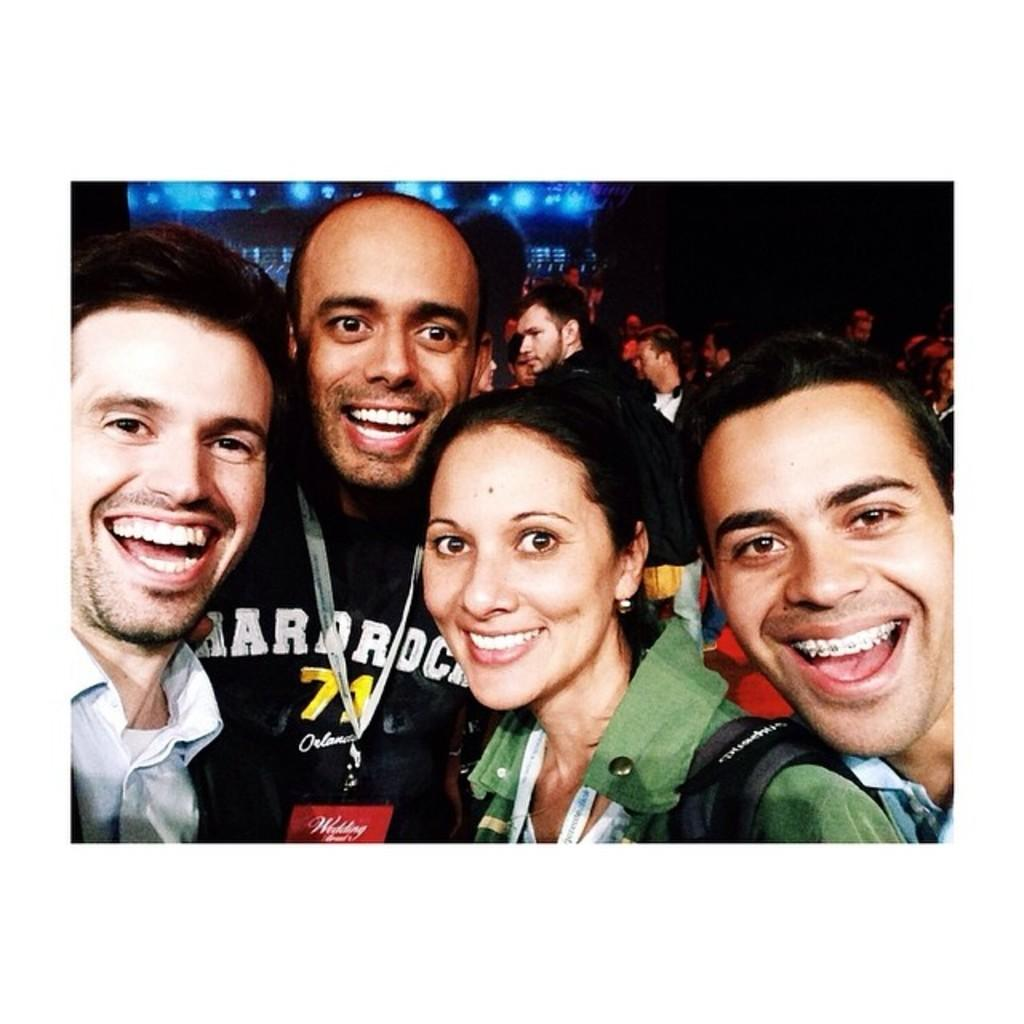How many people are in the image? There are four persons in the image. What can be observed about the attire of the persons? The persons are wearing different color dresses. What is the facial expression of the persons? The persons are smiling. Can you describe the background of the image? There are other persons in the background of the image, and there are blue color lights in the background. The background is dark in color. How does the zephyr affect the girl in the image? There is no girl or zephyr present in the image. What day of the week is depicted in the image? The provided facts do not mention any specific day of the week, so it cannot be determined from the image. 